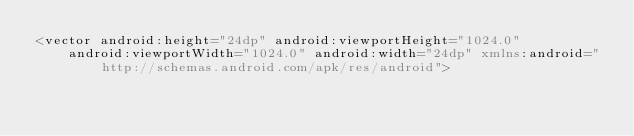<code> <loc_0><loc_0><loc_500><loc_500><_XML_><vector android:height="24dp" android:viewportHeight="1024.0"
    android:viewportWidth="1024.0" android:width="24dp" xmlns:android="http://schemas.android.com/apk/res/android"></code> 